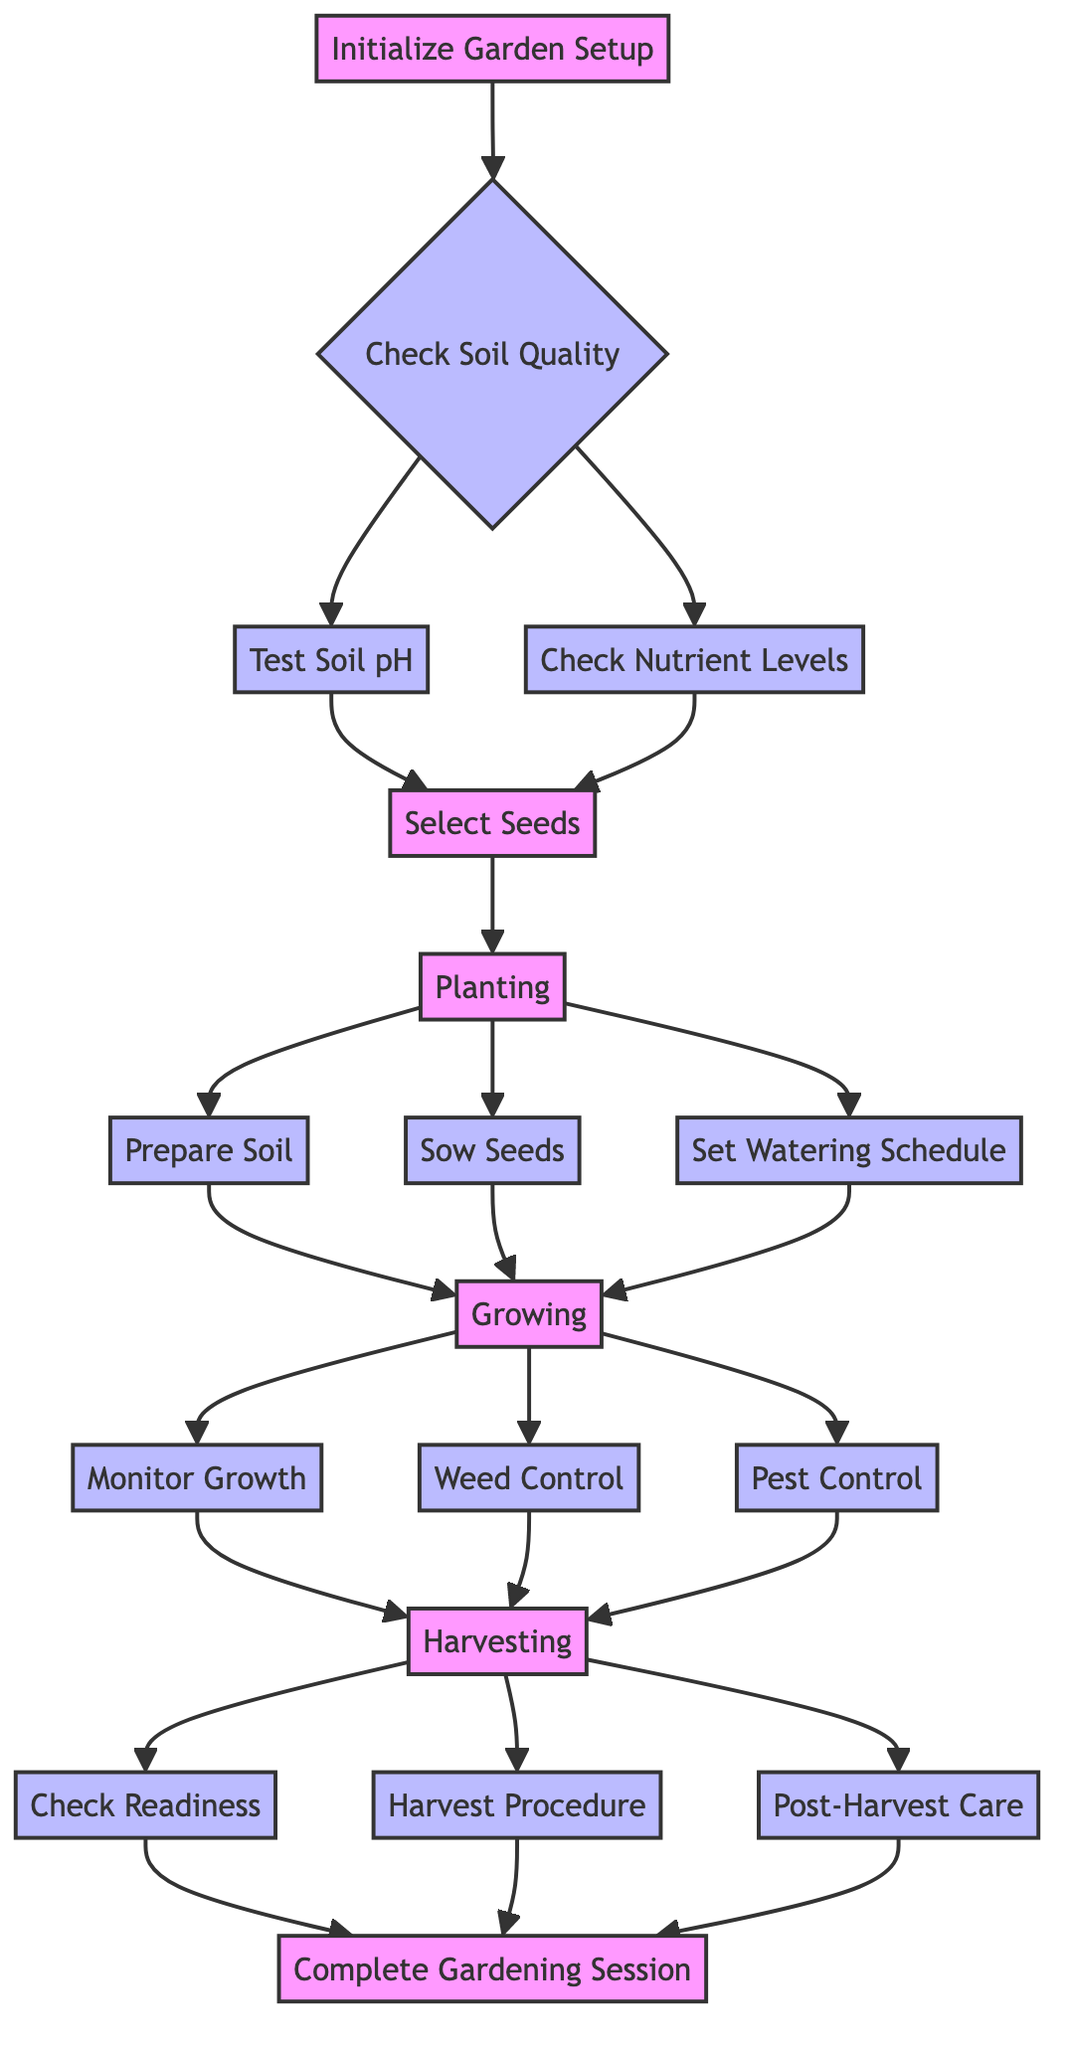What is the first step in the algorithm? The diagram starts with the node "Initialize Garden Setup," which indicates the first action to take in the process.
Answer: Initialize Garden Setup How many main stages are there in the diagram? The diagram has five main stages: Check Soil Quality, Planting, Growing, Harvesting, and Complete Gardening Session.
Answer: Five What is the output node that signifies the end of the process? The final node in the flowchart is "Complete Gardening Session," which indicates the end of the gardening process.
Answer: Complete Gardening Session What action follows "Check Nutrient Levels"? The next action that follows "Check Nutrient Levels" is "Select Seeds," as both nutrients and pH tests lead to the seed selection.
Answer: Select Seeds Which node comes after "Weed Control"? The "Weed Control" node leads directly to the "Harvesting" stage, meaning the next action after weed control is moving to harvesting.
Answer: Harvesting How many actions are involved in the harvesting process? The harvesting process includes three actions: Check Readiness, Harvest Procedure, and Post-Harvest Care, making a total of three actions.
Answer: Three What is the common outcome for both "Monitor Growth" and "Weed Control"? Both "Monitor Growth" and "Weed Control" lead to the same subsequent action, which is "Harvesting," indicating their contributions to achieving the harvest stage.
Answer: Harvesting What is the implication of testing the soil pH? If the soil pH is not within the specified range (less than 6 or greater than 7.5), it implies that corrective adjustments must be made to ensure optimal soil conditions.
Answer: Adjust soil Which action must be completed before planting seeds? Prior to sowing seeds, "Prepare Soil" must be completed, indicating that soil preparation is essential for successful planting.
Answer: Prepare Soil What essential aspect of the growing phase is highlighted? The essential aspects include "Monitor Growth," "Weed Control," and "Pest Control," emphasizing the ongoing care required during the growth phase of the vegetables.
Answer: Monitor Growth, Weed Control, Pest Control 